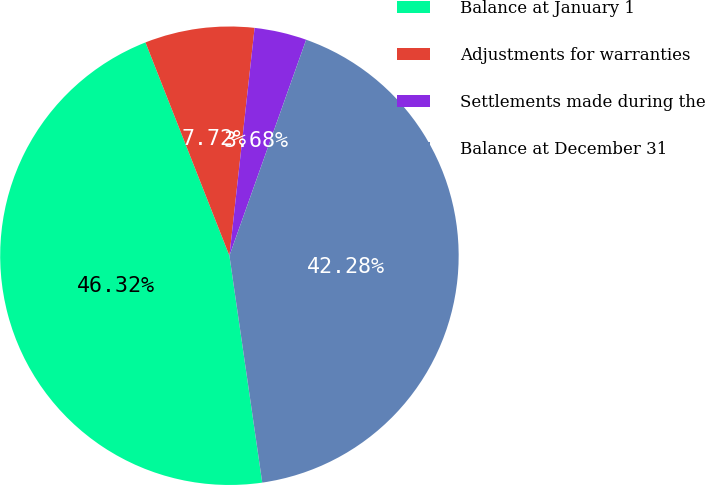<chart> <loc_0><loc_0><loc_500><loc_500><pie_chart><fcel>Balance at January 1<fcel>Adjustments for warranties<fcel>Settlements made during the<fcel>Balance at December 31<nl><fcel>46.32%<fcel>7.72%<fcel>3.68%<fcel>42.28%<nl></chart> 